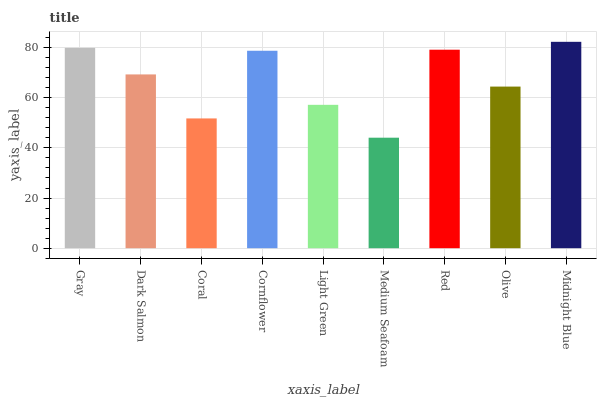Is Medium Seafoam the minimum?
Answer yes or no. Yes. Is Midnight Blue the maximum?
Answer yes or no. Yes. Is Dark Salmon the minimum?
Answer yes or no. No. Is Dark Salmon the maximum?
Answer yes or no. No. Is Gray greater than Dark Salmon?
Answer yes or no. Yes. Is Dark Salmon less than Gray?
Answer yes or no. Yes. Is Dark Salmon greater than Gray?
Answer yes or no. No. Is Gray less than Dark Salmon?
Answer yes or no. No. Is Dark Salmon the high median?
Answer yes or no. Yes. Is Dark Salmon the low median?
Answer yes or no. Yes. Is Gray the high median?
Answer yes or no. No. Is Light Green the low median?
Answer yes or no. No. 